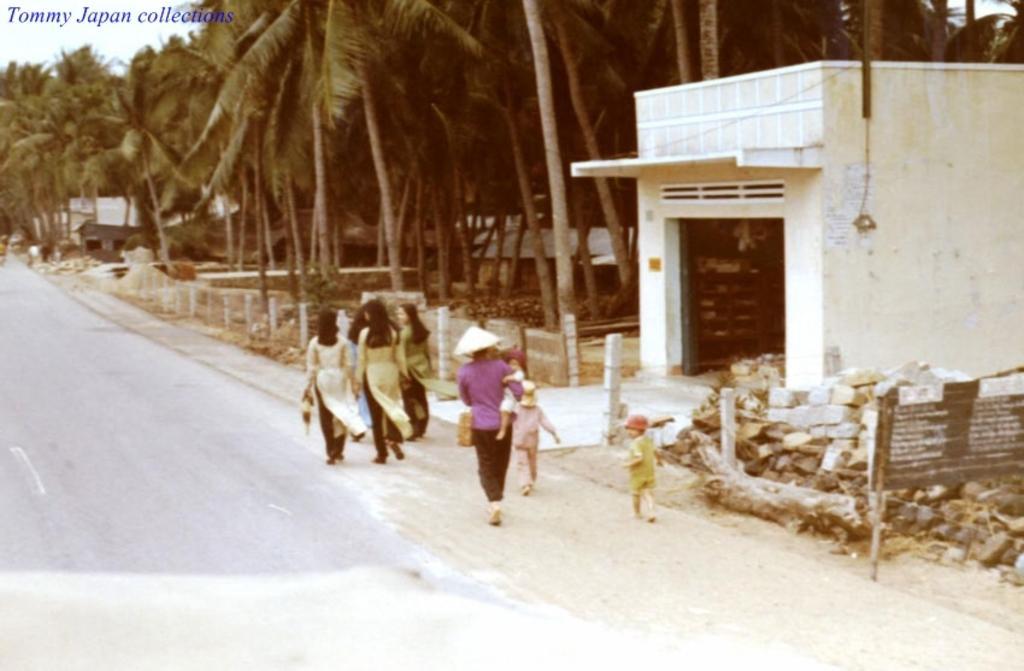How would you summarize this image in a sentence or two? In this image there are a group of people walking, and one person is holding a baby, at the bottom there is road. And in the background there are some trees, house, poles, rocks and board. On the board there is text and at the top of the image there is text. 